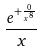Convert formula to latex. <formula><loc_0><loc_0><loc_500><loc_500>\frac { e ^ { + \frac { 0 } { x ^ { 8 } } } } { x }</formula> 